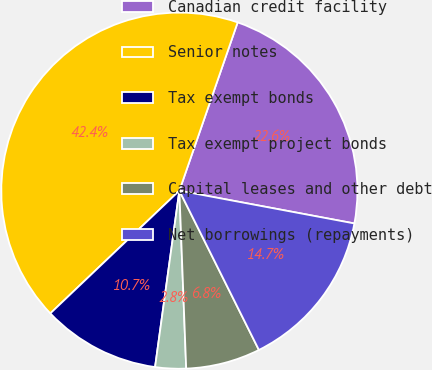<chart> <loc_0><loc_0><loc_500><loc_500><pie_chart><fcel>Canadian credit facility<fcel>Senior notes<fcel>Tax exempt bonds<fcel>Tax exempt project bonds<fcel>Capital leases and other debt<fcel>Net borrowings (repayments)<nl><fcel>22.64%<fcel>42.41%<fcel>10.72%<fcel>2.79%<fcel>6.76%<fcel>14.68%<nl></chart> 